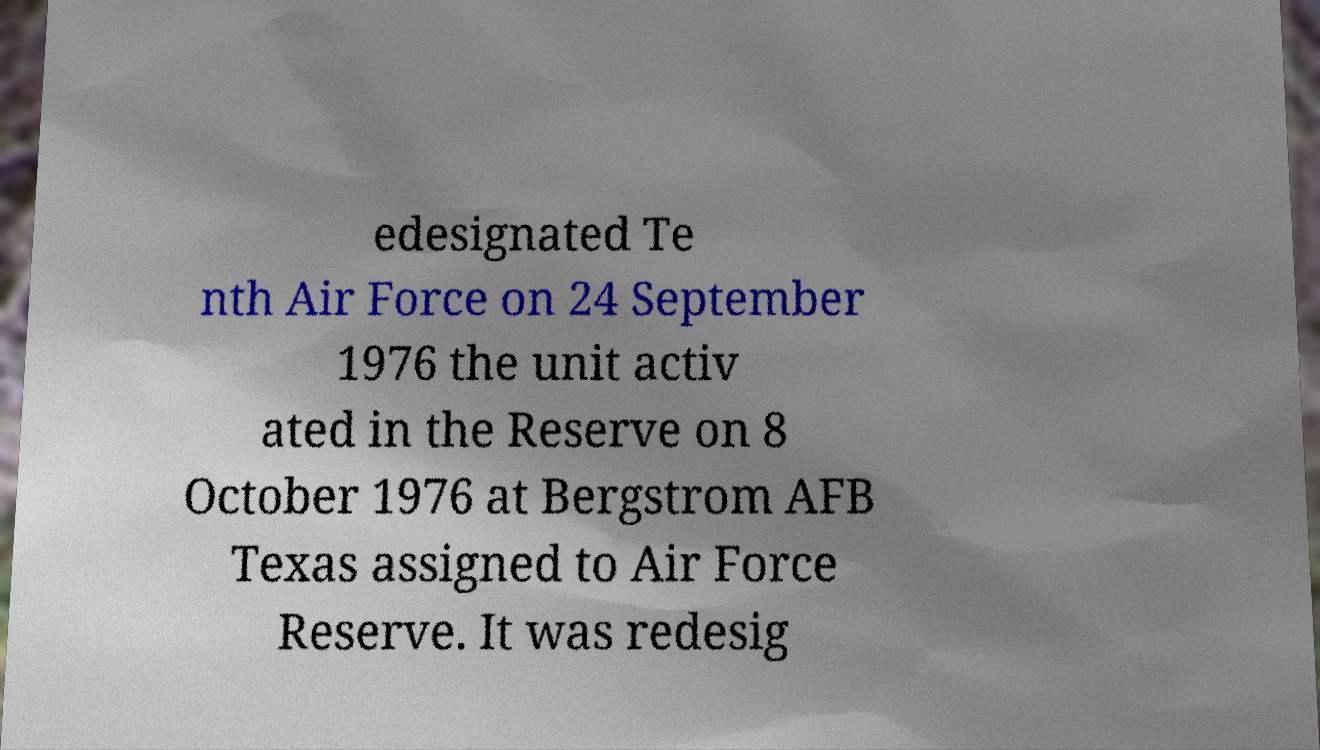Can you accurately transcribe the text from the provided image for me? edesignated Te nth Air Force on 24 September 1976 the unit activ ated in the Reserve on 8 October 1976 at Bergstrom AFB Texas assigned to Air Force Reserve. It was redesig 